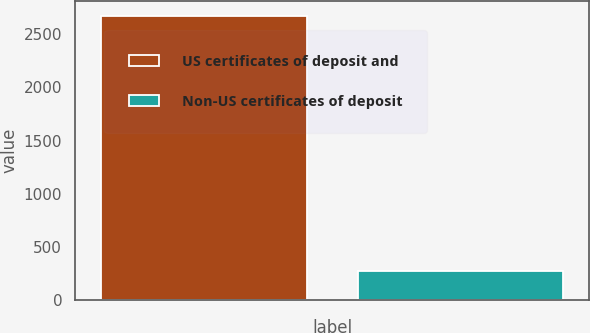<chart> <loc_0><loc_0><loc_500><loc_500><bar_chart><fcel>US certificates of deposit and<fcel>Non-US certificates of deposit<nl><fcel>2677<fcel>277<nl></chart> 